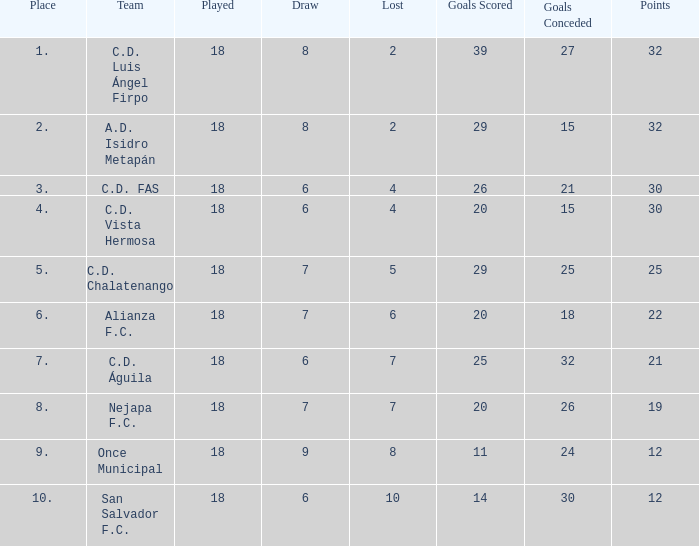Which team has conceded fewer than 25 goals and ranks higher than 3rd place? A.D. Isidro Metapán. 